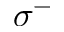Convert formula to latex. <formula><loc_0><loc_0><loc_500><loc_500>\sigma ^ { - }</formula> 